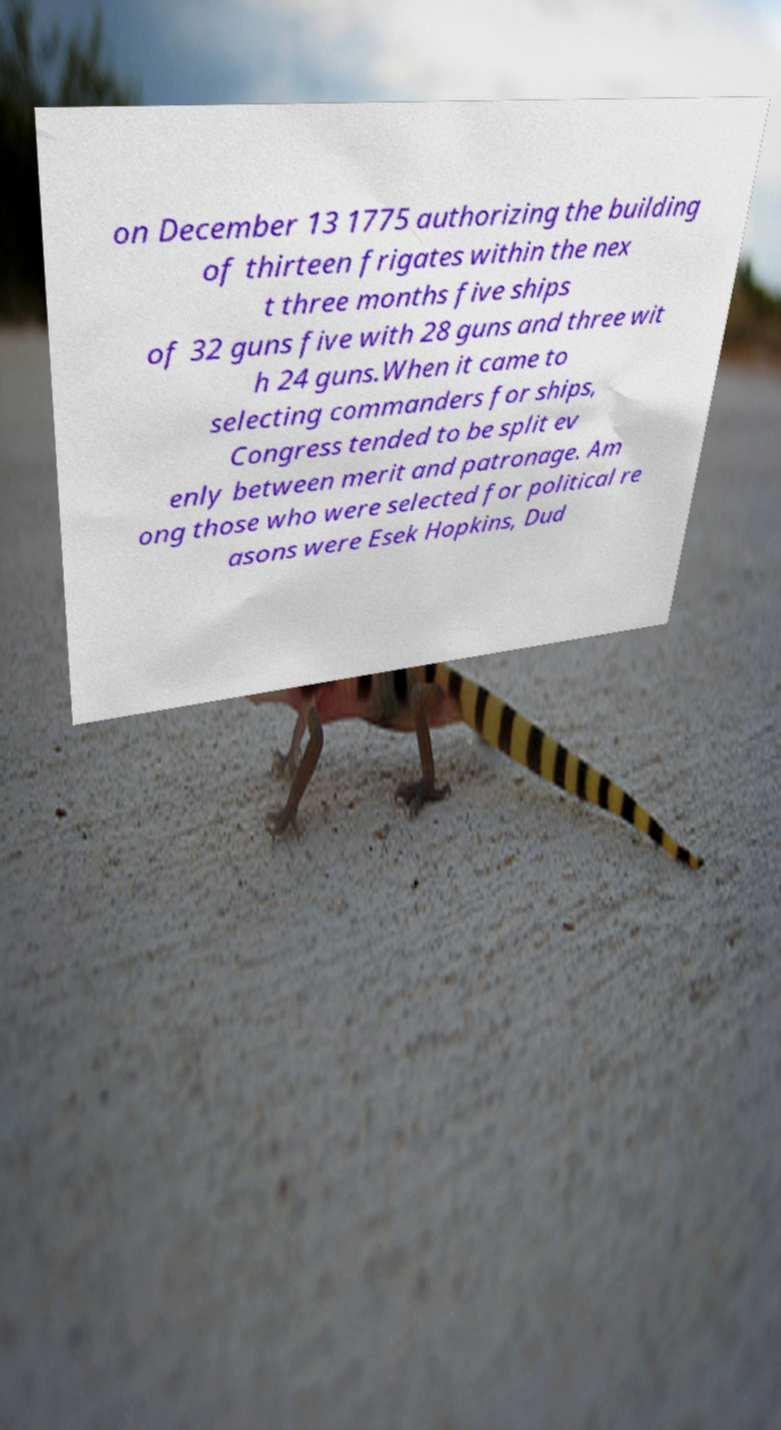What messages or text are displayed in this image? I need them in a readable, typed format. on December 13 1775 authorizing the building of thirteen frigates within the nex t three months five ships of 32 guns five with 28 guns and three wit h 24 guns.When it came to selecting commanders for ships, Congress tended to be split ev enly between merit and patronage. Am ong those who were selected for political re asons were Esek Hopkins, Dud 